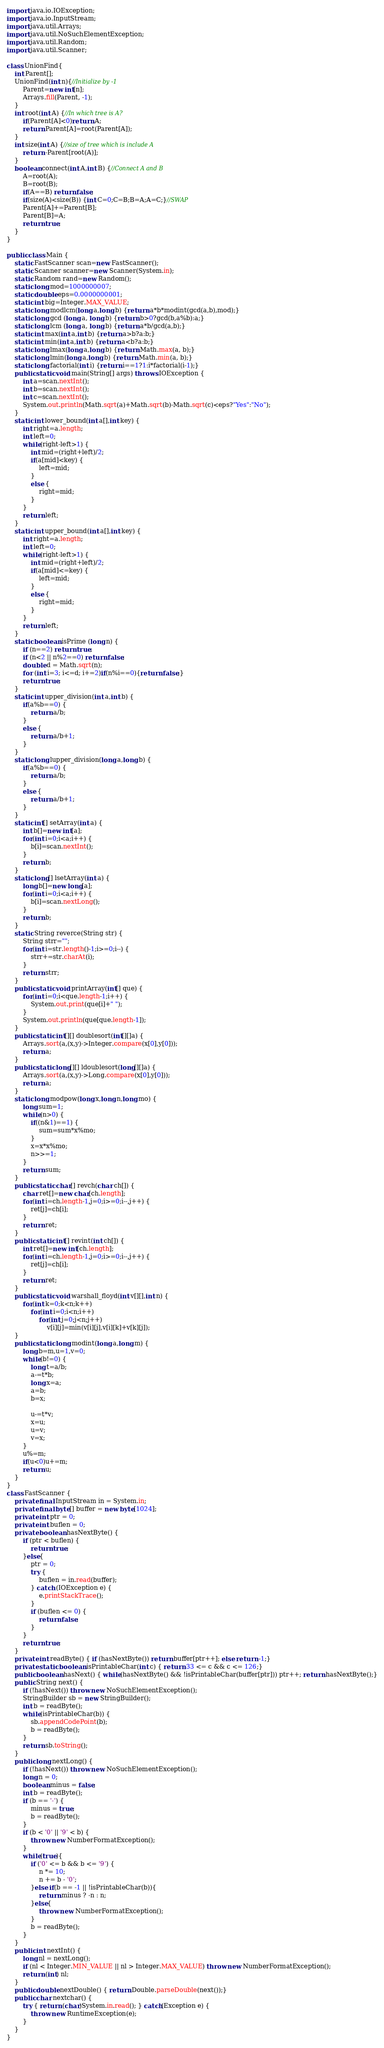<code> <loc_0><loc_0><loc_500><loc_500><_Java_>import java.io.IOException;
import java.io.InputStream;
import java.util.Arrays;
import java.util.NoSuchElementException;
import java.util.Random;
import java.util.Scanner;

class UnionFind{
	int Parent[];
	UnionFind(int n){//Initialize by -1
		Parent=new int[n];
		Arrays.fill(Parent, -1);
	}
	int root(int A) {//In which tree is A?
		if(Parent[A]<0)return A;
		return Parent[A]=root(Parent[A]);
	}
	int size(int A) {//size of tree which is include A
		return -Parent[root(A)];
	}
	boolean connect(int A,int B) {//Connect A and B
		A=root(A);
		B=root(B);
		if(A==B) return false;
		if(size(A)<size(B)) {int C=0;C=B;B=A;A=C;}//SWAP
		Parent[A]+=Parent[B];
		Parent[B]=A;
		return true;
	}
}

public class Main {
	static FastScanner scan=new FastScanner();
	static Scanner scanner=new Scanner(System.in);
	static Random rand=new Random();
	static long mod=1000000007;
	static double eps=0.0000000001;
	static int big=Integer.MAX_VALUE;
	static long modlcm(long a,long b) {return a*b*modint(gcd(a,b),mod);}
	static long gcd (long a, long b) {return b>0?gcd(b,a%b):a;}
	static long lcm (long a, long b) {return a*b/gcd(a,b);}
	static int max(int a,int b) {return a>b?a:b;}
	static int min(int a,int b) {return a<b?a:b;}
	static long lmax(long a,long b) {return Math.max(a, b);}
	static long lmin(long a,long b) {return Math.min(a, b);}
	static long factorial(int i) {return i==1?1:i*factorial(i-1);}
	public static void main(String[] args) throws IOException {
		int a=scan.nextInt();
		int b=scan.nextInt();
		int c=scan.nextInt();
		System.out.println(Math.sqrt(a)+Math.sqrt(b)-Math.sqrt(c)<eps?"Yes":"No");
	}
	static int lower_bound(int a[],int key) {
		int right=a.length;
		int left=0;
		while(right-left>1) {
			int mid=(right+left)/2;
			if(a[mid]<key) {
				left=mid;
			}
			else {
				right=mid;
			}
		}
		return left;
	}
	static int upper_bound(int a[],int key) {
		int right=a.length;
		int left=0;
		while(right-left>1) {
			int mid=(right+left)/2;
			if(a[mid]<=key) {
				left=mid;
			}
			else {
				right=mid;
			}
		}
		return left;
	}
	static boolean isPrime (long n) {
		if (n==2) return true;
		if (n<2 || n%2==0) return false;
		double d = Math.sqrt(n);
		for (int i=3; i<=d; i+=2)if(n%i==0){return false;}
		return true;
	}
	static int upper_division(int a,int b) {
		if(a%b==0) {
			return a/b;
		}
		else {
			return a/b+1;
		}
	}
	static long lupper_division(long a,long b) {
		if(a%b==0) {
			return a/b;
		}
		else {
			return a/b+1;
		}
	}
	static int[] setArray(int a) {
		int b[]=new int[a];
		for(int i=0;i<a;i++) {
			b[i]=scan.nextInt();
		}
		return b;
	}
	static long[] lsetArray(int a) {
		long b[]=new long[a];
		for(int i=0;i<a;i++) {
			b[i]=scan.nextLong();
		}
		return b;
	}
	static String reverce(String str) {
		String strr="";
		for(int i=str.length()-1;i>=0;i--) {
			strr+=str.charAt(i);
		}
		return strr;
	}
	public static void printArray(int[] que) {
		for(int i=0;i<que.length-1;i++) {
			System.out.print(que[i]+" ");
		}
		System.out.println(que[que.length-1]);
	}
	public static int[][] doublesort(int[][]a) {
		Arrays.sort(a,(x,y)->Integer.compare(x[0],y[0]));
		return a;
	}
	public static long[][] ldoublesort(long[][]a) {
		Arrays.sort(a,(x,y)->Long.compare(x[0],y[0]));
		return a;
	}
	static long modpow(long x,long n,long mo) {
		long sum=1;
		while(n>0) {
			if((n&1)==1) {
				sum=sum*x%mo;
			}
			x=x*x%mo;
			n>>=1;
		}
		return sum;
	}
	public static char[] revch(char ch[]) {
		char ret[]=new char[ch.length];
		for(int i=ch.length-1,j=0;i>=0;i--,j++) {
			ret[j]=ch[i];
		}
		return ret;
	}
	public static int[] revint(int ch[]) {
		int ret[]=new int[ch.length];
		for(int i=ch.length-1,j=0;i>=0;i--,j++) {
			ret[j]=ch[i];
		}
		return ret;
	}
	public static void warshall_floyd(int v[][],int n) {
		for(int k=0;k<n;k++)
			for(int i=0;i<n;i++)
				for(int j=0;j<n;j++)
					v[i][j]=min(v[i][j],v[i][k]+v[k][j]);
	}
	public static long modint(long a,long m) {
		long b=m,u=1,v=0;
		while(b!=0) {
			long t=a/b;
			a-=t*b;
			long x=a;
			a=b;
			b=x;

			u-=t*v;
			x=u;
			u=v;
			v=x;
		}
		u%=m;
		if(u<0)u+=m;
		return u;
	}
}
class FastScanner {
	private final InputStream in = System.in;
	private final byte[] buffer = new byte[1024];
	private int ptr = 0;
	private int buflen = 0;
	private boolean hasNextByte() {
		if (ptr < buflen) {
			return true;
		}else{
			ptr = 0;
			try {
				buflen = in.read(buffer);
			} catch (IOException e) {
				e.printStackTrace();
			}
			if (buflen <= 0) {
				return false;
			}
		}
		return true;
	}
	private int readByte() { if (hasNextByte()) return buffer[ptr++]; else return -1;}
	private static boolean isPrintableChar(int c) { return 33 <= c && c <= 126;}
	public boolean hasNext() { while(hasNextByte() && !isPrintableChar(buffer[ptr])) ptr++; return hasNextByte();}
	public String next() {
		if (!hasNext()) throw new NoSuchElementException();
		StringBuilder sb = new StringBuilder();
		int b = readByte();
		while(isPrintableChar(b)) {
			sb.appendCodePoint(b);
			b = readByte();
		}
		return sb.toString();
	}
	public long nextLong() {
		if (!hasNext()) throw new NoSuchElementException();
		long n = 0;
		boolean minus = false;
		int b = readByte();
		if (b == '-') {
			minus = true;
			b = readByte();
		}
		if (b < '0' || '9' < b) {
			throw new NumberFormatException();
		}
		while(true){
			if ('0' <= b && b <= '9') {
				n *= 10;
				n += b - '0';
			}else if(b == -1 || !isPrintableChar(b)){
				return minus ? -n : n;
			}else{
				throw new NumberFormatException();
			}
			b = readByte();
		}
	}
	public int nextInt() {
		long nl = nextLong();
		if (nl < Integer.MIN_VALUE || nl > Integer.MAX_VALUE) throw new NumberFormatException();
		return (int) nl;
	}
	public double nextDouble() { return Double.parseDouble(next());}
	public char nextchar() {
		try { return (char)System.in.read(); } catch(Exception e) {
			throw new RuntimeException(e);
		}
	}
}
</code> 